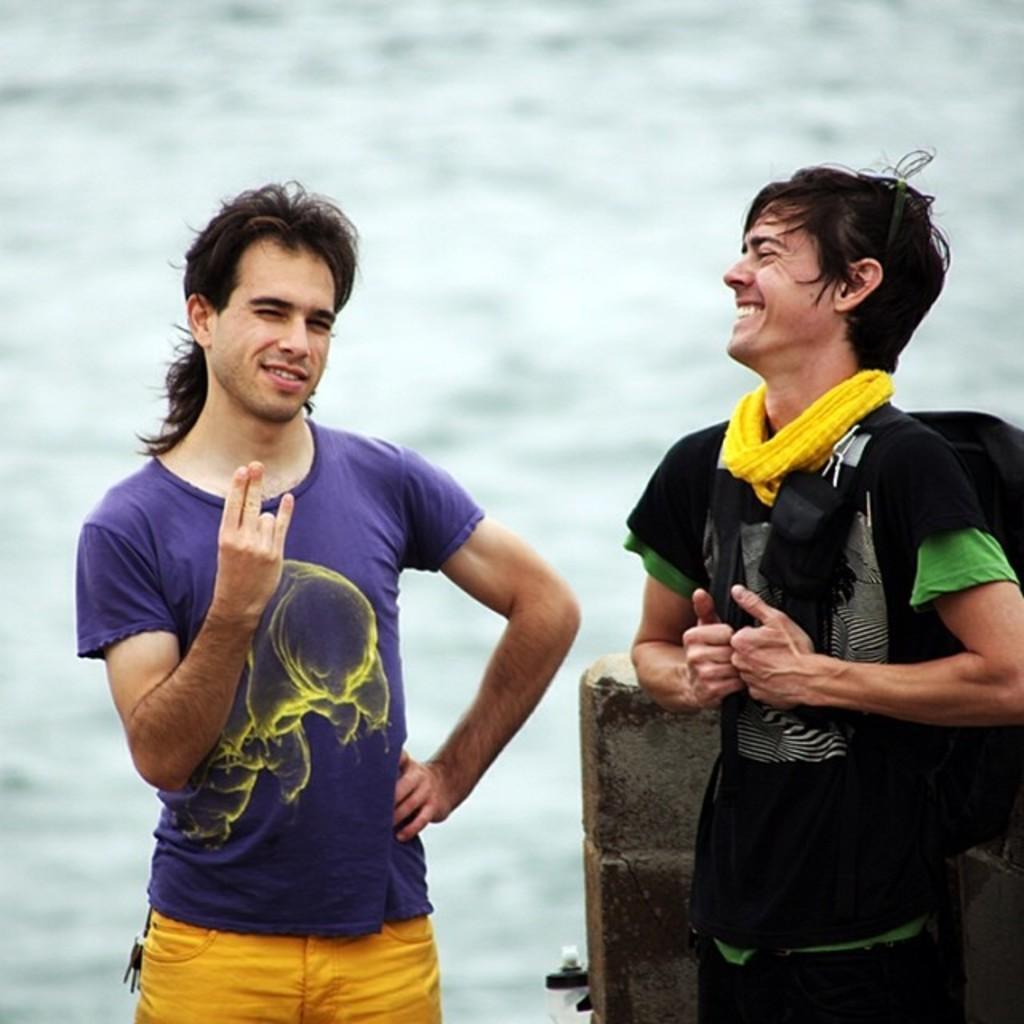Please provide a concise description of this image. In the picture we can see two men are standing, one man is in purple color T-shirt and showing his two fingers and one man is in black T-shirt and wearing a bag and laughing and behind him we can see a wall and the water behind it. 